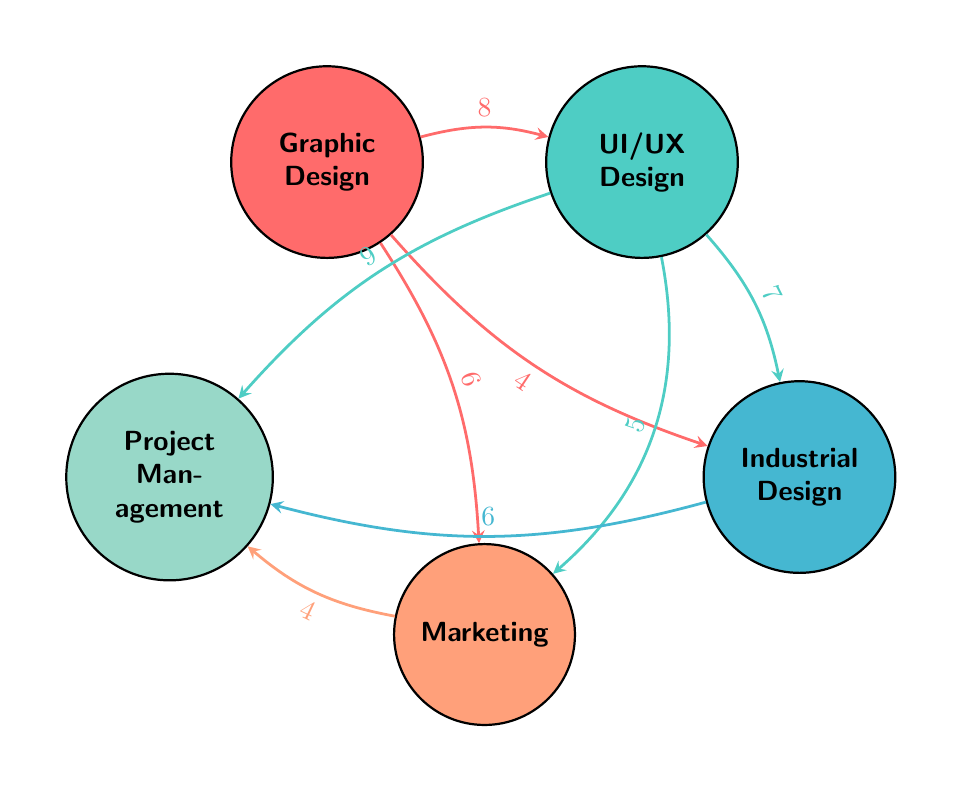what's the number of nodes in the diagram? The diagram contains five distinct nodes, which are Graphic Design, UI/UX Design, Industrial Design, Marketing, and Project Management.
Answer: 5 which department has the highest collaboration value with UI/UX Design? By examining the connections originating from UI/UX Design, the highest collaboration value is with Project Management, which has a value of 9.
Answer: Project Management what is the collaboration value between Graphic Design and Marketing? The connection between Graphic Design and Marketing has a value of 6, indicating the strength of collaboration between these two departments.
Answer: 6 how many total links are present in the diagram? The links can be counted by examining the connections between the nodes, resulting in a total of eight links in the diagram.
Answer: 8 which department has the lowest collaboration value with Project Management? Marketing has the lowest collaboration value with Project Management, which has a value of 4, among the connected departments.
Answer: Marketing if we consider the three highest collaboration values, which departments are involved? The three highest collaboration values are 9 (UI/UX Design to Project Management), 8 (Graphic Design to UI/UX Design), and 7 (UI/UX Design to Industrial Design), involving UI/UX Design and Project Management among others.
Answer: UI/UX Design, Project Management which two departments have a direct collaboration value of 4? The direct collaboration between Graphic Design and Industrial Design also has a value of 4 as indicated in the diagram.
Answer: Graphic Design, Industrial Design what is the total collaboration value for Project Management from all participating departments? To find the total collaboration value for Project Management, we sum its collaboration values from all connected departments: 9 (from UI/UX Design) + 6 (from Industrial Design) + 4 (from Marketing) = 19.
Answer: 19 